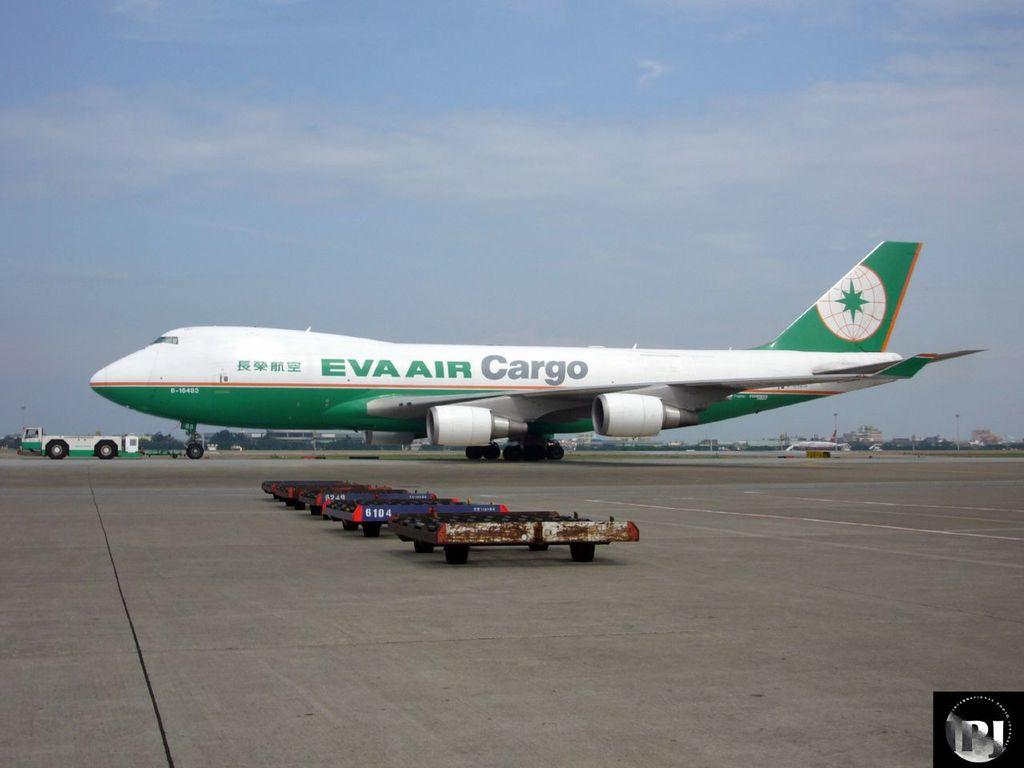<image>
Describe the image concisely. An EVa Air cargo plane that is green and white sits on an airport runway. 